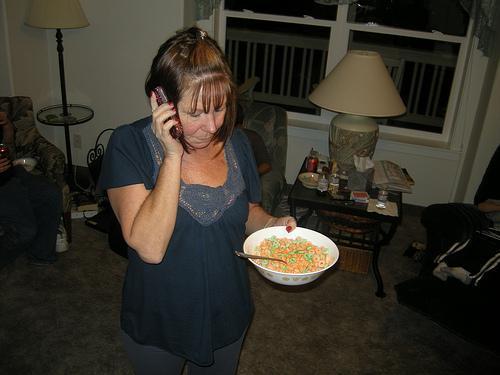How many bowls are in the picture?
Give a very brief answer. 1. 